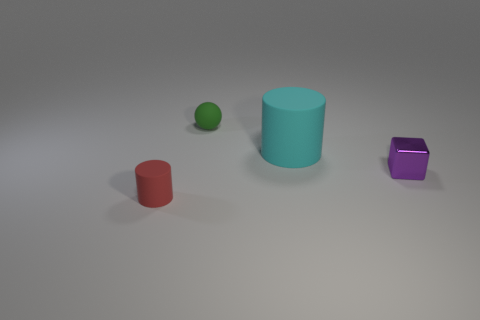Add 1 tiny green balls. How many objects exist? 5 Subtract all spheres. How many objects are left? 3 Subtract 0 red cubes. How many objects are left? 4 Subtract all cyan matte objects. Subtract all metallic objects. How many objects are left? 2 Add 4 small purple cubes. How many small purple cubes are left? 5 Add 4 purple cubes. How many purple cubes exist? 5 